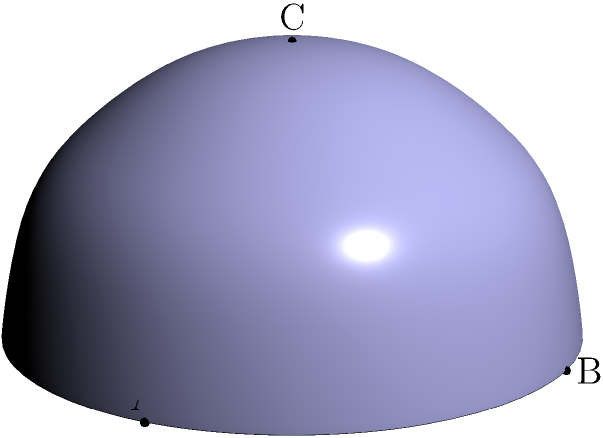In the context of non-Euclidean geometry, consider a spherical triangle ABC on the surface of a unit sphere, as shown in the figure. If the angles of this triangle are 90°, 90°, and 90°, what is the sum of these angles, and how does this relate to the curvature of space on the sphere's surface? Let's approach this step-by-step:

1) In Euclidean geometry, the sum of angles in a triangle is always 180°. However, on a spherical surface, this is not the case.

2) On a sphere, straight lines are represented by great circles (the intersection of the sphere with a plane passing through its center).

3) The triangle ABC shown is formed by the intersection of three great circles, each perpendicular to the others. This forms a spherical right triangle with three right angles.

4) The sum of the angles in this spherical triangle is:
   $90° + 90° + 90° = 270°$

5) This sum exceeds 180° by 90°. The difference between the angle sum and 180° is called the spherical excess.

6) The spherical excess is directly related to the area of the triangle on the sphere's surface. For a unit sphere, the area of the triangle is numerically equal to the spherical excess in radians.

7) The fact that the angle sum is greater than 180° is a clear indication of positive curvature. In spaces with positive curvature, like a sphere's surface, parallel lines converge and the sum of angles in a triangle is always greater than 180°.

8) This demonstrates how the geometry of a curved space (like a sphere's surface) differs from the flat Euclidean plane, visualizing an aspect of non-Euclidean geometry.

9) In the context of hospice care, this concept could be metaphorically applied to understand how different perspectives (represented by the angles) can add up to more than expected when considering the holistic needs of patients and families.
Answer: 270°; indicates positive curvature 